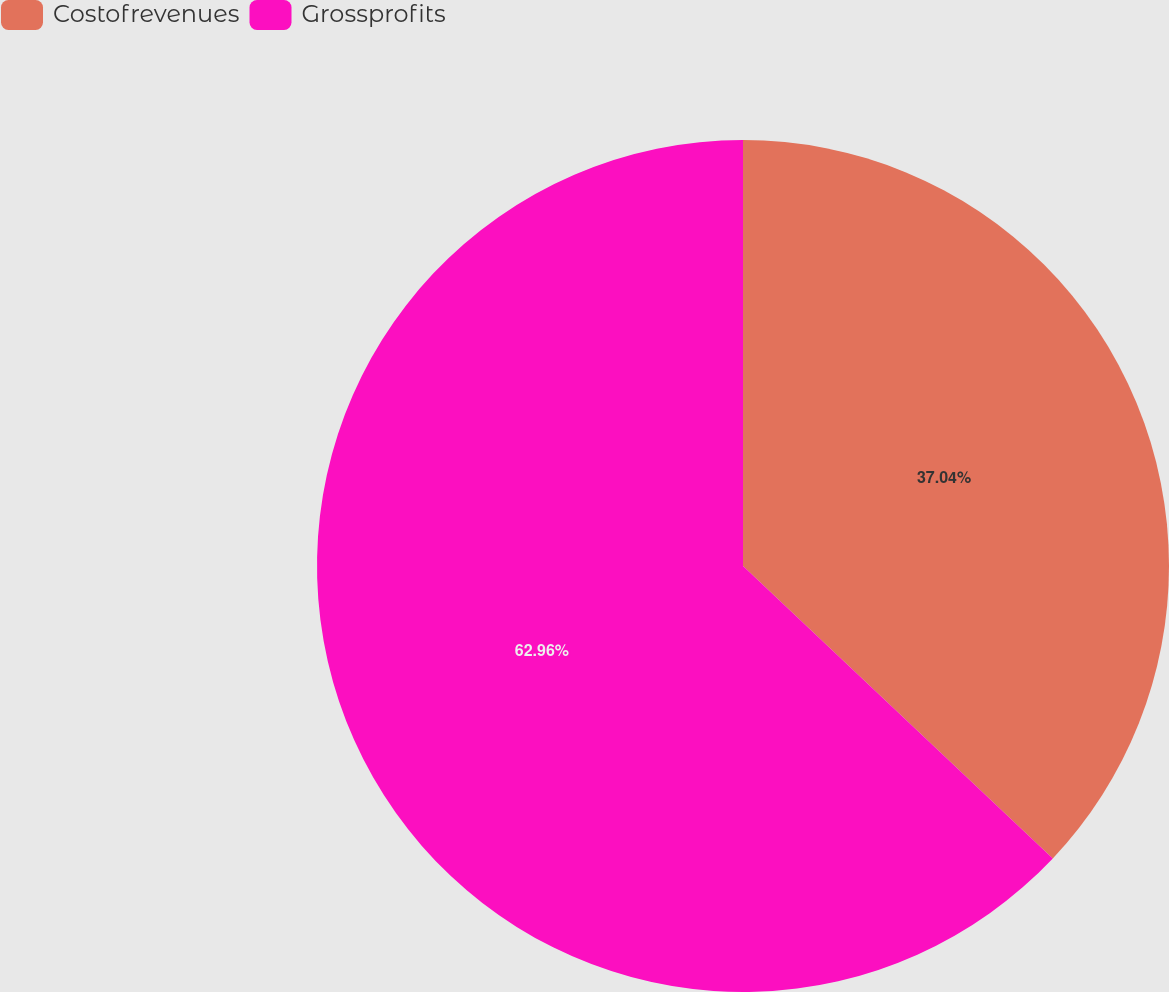<chart> <loc_0><loc_0><loc_500><loc_500><pie_chart><fcel>Costofrevenues<fcel>Grossprofits<nl><fcel>37.04%<fcel>62.96%<nl></chart> 